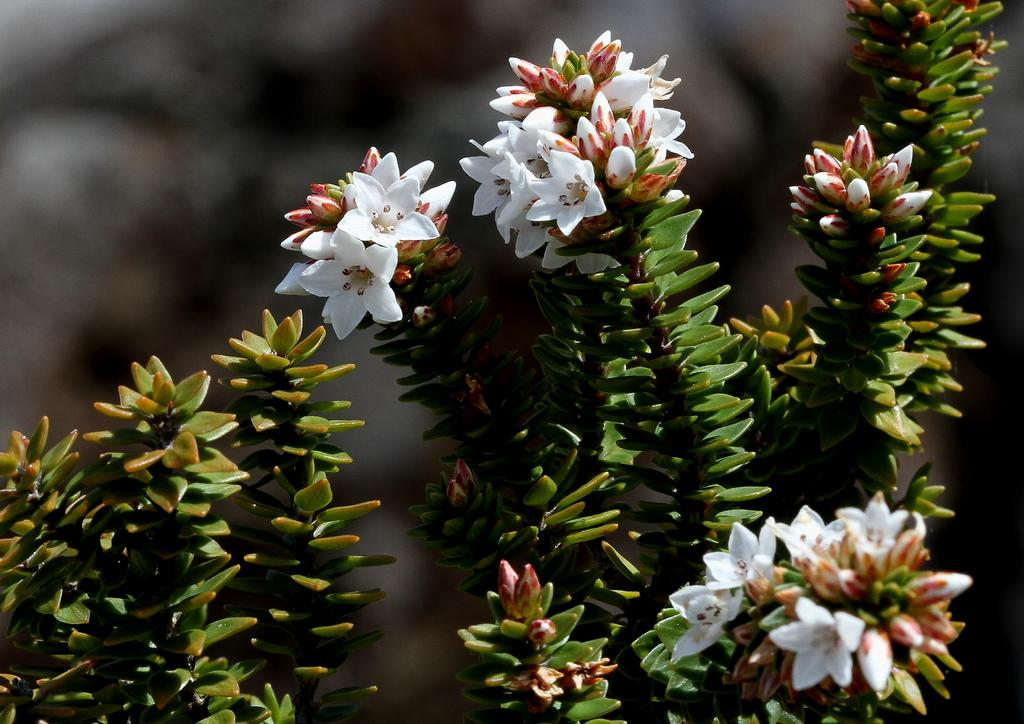What is present in the image? There is a plant in the image. Can you describe the flowers on the plant? The plant has white flowers. What is the purpose of the basket in the image? There is no basket present in the image. The conversation focuses on the plant and its white flowers, as mentioned in the facts. 